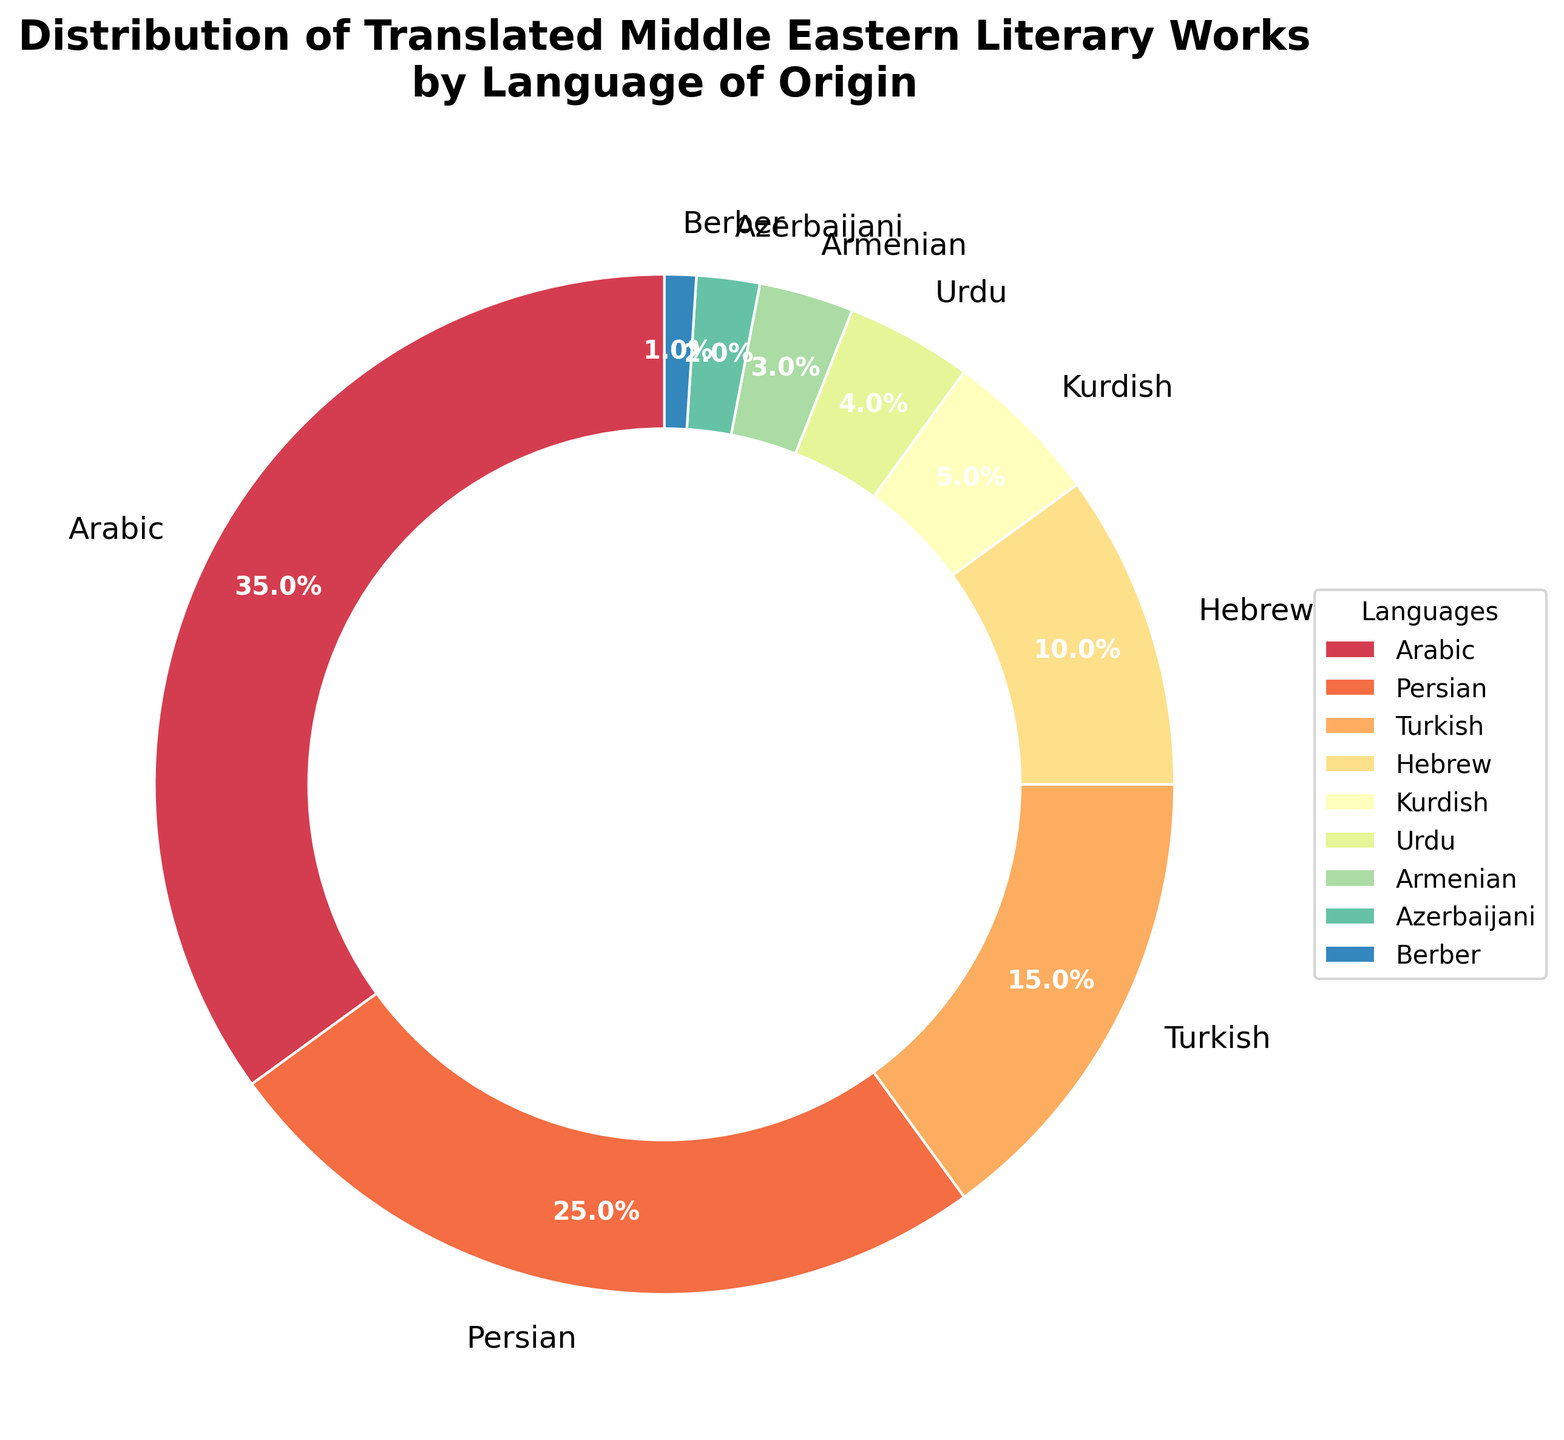What percentage of translated Middle Eastern literary works originates from Arabic? The pie chart indicates that the segment labeled "Arabic" represents 35% of the total distribution, which directly shows the percentage of translations originating from Arabic is 35%
Answer: 35% Which language has the second highest percentage of translated works? By looking at the pie chart, the segment with the second largest size—labeled "Persian"—has a percentage of 25%, making it the language with the second highest percentage of translated works
Answer: Persian How do the percentages of translated works from Kurdish and Urdu compare? The pie chart shows that the Kurdish segment accounts for 5% while the Urdu segment accounts for 4%. Hence, Kurdish has a higher percentage than Urdu by 1%
Answer: Kurdish is 1% more than Urdu What is the combined percentage of translated works originating from Hebrew, Kurdish, and Urdu? The pie chart shows Hebrew at 10%, Kurdish at 5%, and Urdu at 4%. The combined percentage is calculated as 10% + 5% + 4% = 19%
Answer: 19% Which language has the smallest percentage of translated works? According to the pie chart, the smallest segment is labeled "Berber," which stands at 1%
Answer: Berber How much greater is the percentage of translated works from Persian compared to Turkish? The pie chart shows Persian at 25% and Turkish at 15%. The difference is 25% - 15% = 10%
Answer: Persian is 10% greater than Turkish What is the total percentage of translated works from Armenian and Azerbaijani languages? The pie chart indicates Armenian accounts for 3% and Azerbaijani for 2%. The total percentage is calculated as 3% + 2% = 5%
Answer: 5% Which segment of the pie chart is represented by blue? By referring to the legend and visual attributes of the pie chart, we can determine that the segment colored in blue corresponds to the language labeled "Persian"
Answer: Persian Is the percentage of translated works from Arabic more than double that of Turkish? The chart shows Arabic at 35% and Turkish at 15%. Doubling Turkish gives 15% * 2 = 30%. Since 35% (Arabic) is greater than 30%, Arabic is more than double that of Turkish
Answer: Yes What percentage of the translated works' distribution is shared among the languages Armenian, Azerbaijani, Berber, and Urdu? The pie chart shows percentages of Armenian 3%, Azerbaijani 2%, Berber 1%, and Urdu 4%. Combined, they make 3% + 2% + 1% + 4% = 10%
Answer: 10% 